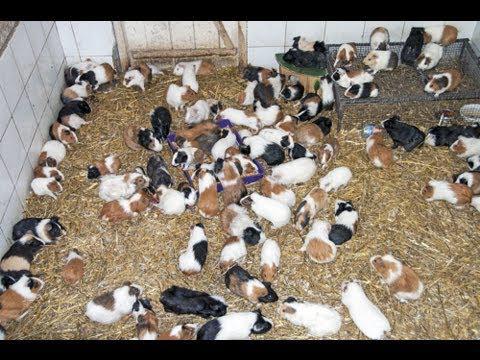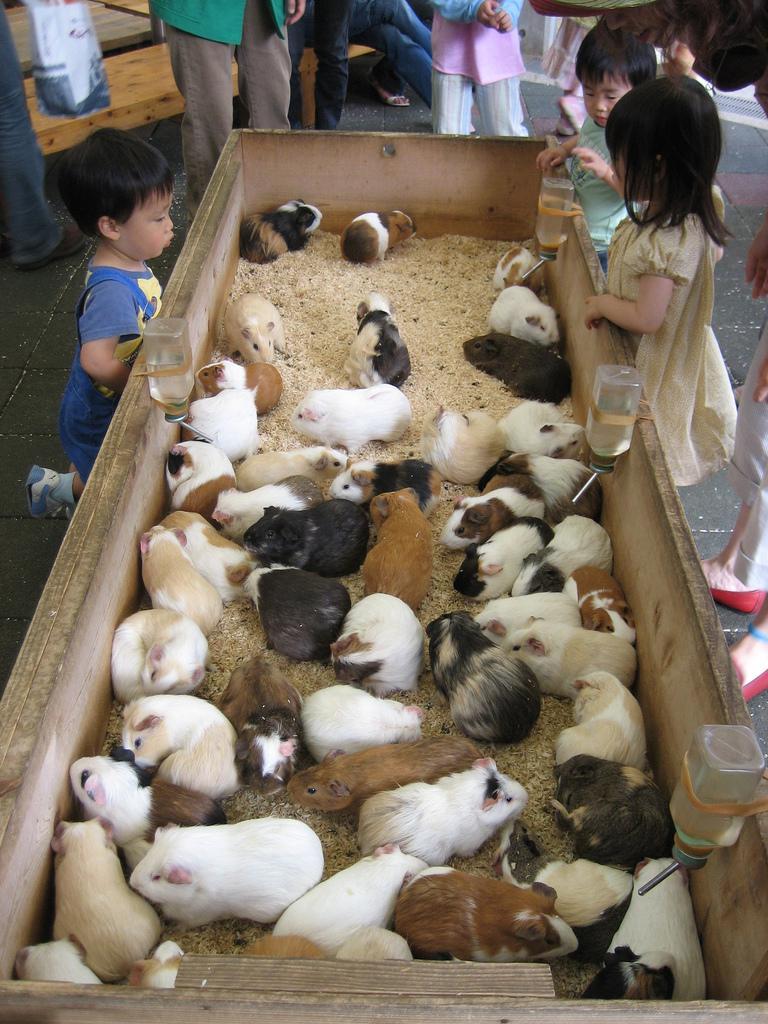The first image is the image on the left, the second image is the image on the right. Analyze the images presented: Is the assertion "The animals in the image on the left are not in an enclosure." valid? Answer yes or no. No. 